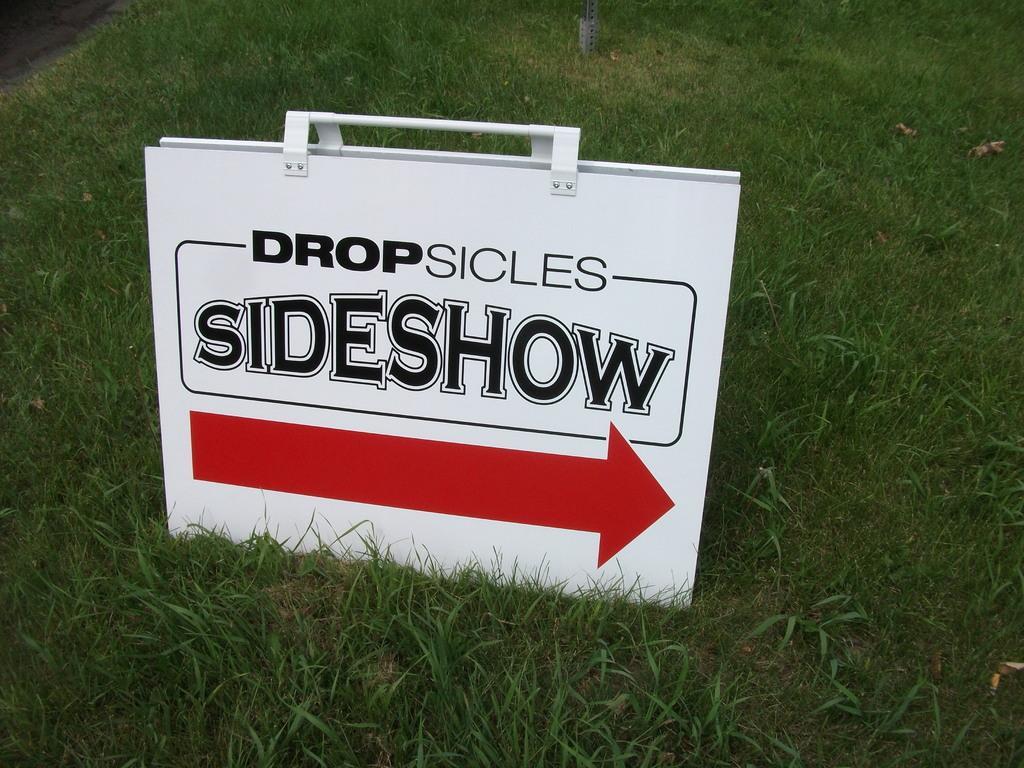Describe this image in one or two sentences. In this picture, we see a white box or a board with text written as "SIDESHOW". We see a red arrow is drawn on the board. At the bottom of the picture, we see the grass. 